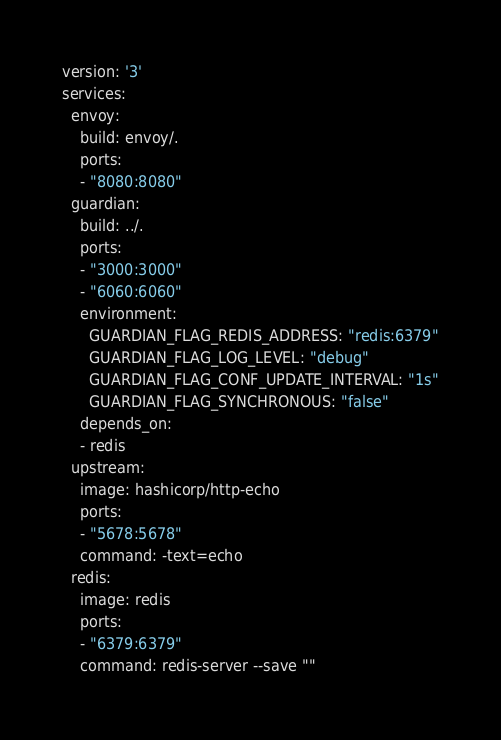<code> <loc_0><loc_0><loc_500><loc_500><_YAML_>version: '3'
services:
  envoy: 
    build: envoy/.
    ports: 
    - "8080:8080"
  guardian:
    build: ../.
    ports:
    - "3000:3000"
    - "6060:6060"
    environment:
      GUARDIAN_FLAG_REDIS_ADDRESS: "redis:6379"
      GUARDIAN_FLAG_LOG_LEVEL: "debug"
      GUARDIAN_FLAG_CONF_UPDATE_INTERVAL: "1s"
      GUARDIAN_FLAG_SYNCHRONOUS: "false"
    depends_on:
    - redis
  upstream:
    image: hashicorp/http-echo
    ports:
    - "5678:5678"
    command: -text=echo
  redis:
    image: redis
    ports:
    - "6379:6379"
    command: redis-server --save ""</code> 